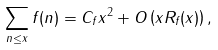<formula> <loc_0><loc_0><loc_500><loc_500>\sum _ { n \leq x } f ( n ) = C _ { f } x ^ { 2 } + O \left ( x R _ { f } ( x ) \right ) ,</formula> 